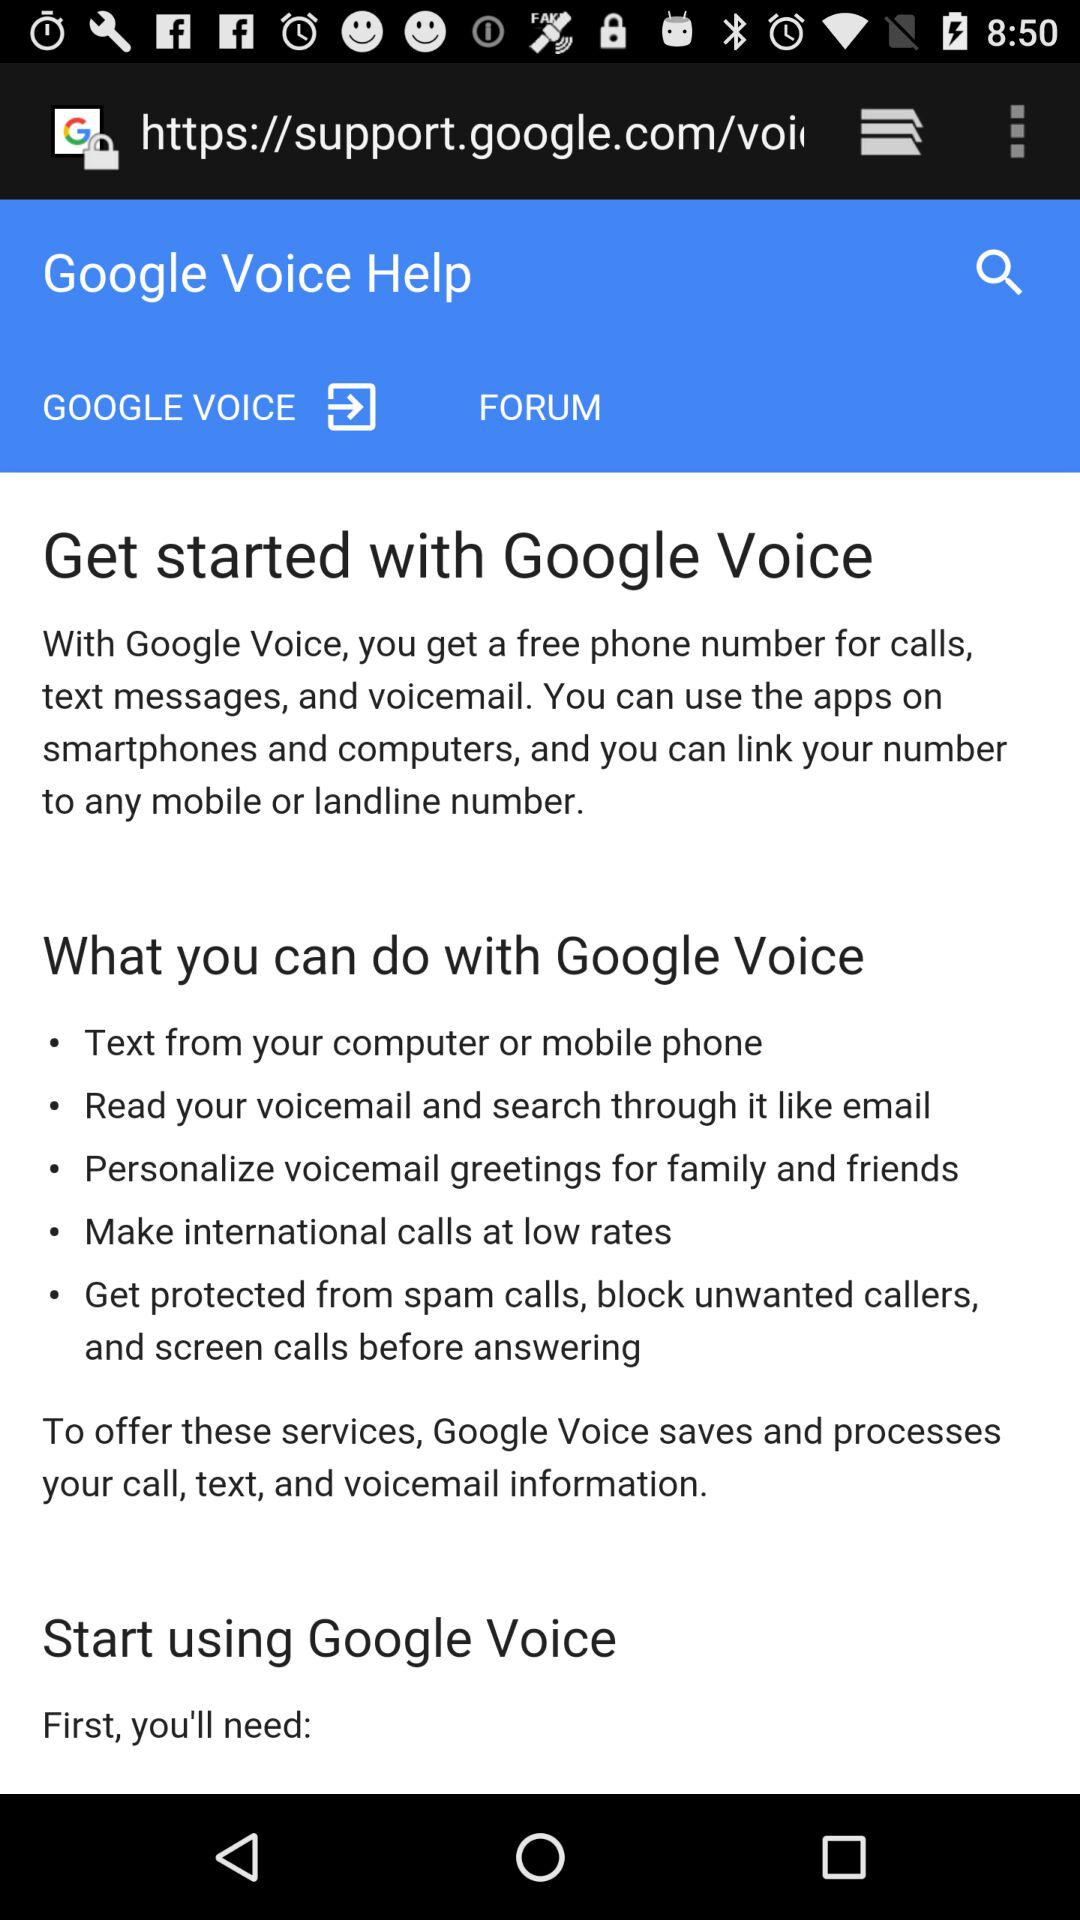Where can we text from? You can text from your computer or mobile phone. 